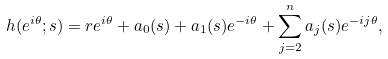Convert formula to latex. <formula><loc_0><loc_0><loc_500><loc_500>h ( e ^ { i \theta } ; s ) = r e ^ { i \theta } + a _ { 0 } ( s ) + a _ { 1 } ( s ) e ^ { - i \theta } + \sum _ { j = 2 } ^ { n } a _ { j } ( s ) e ^ { - i j \theta } ,</formula> 